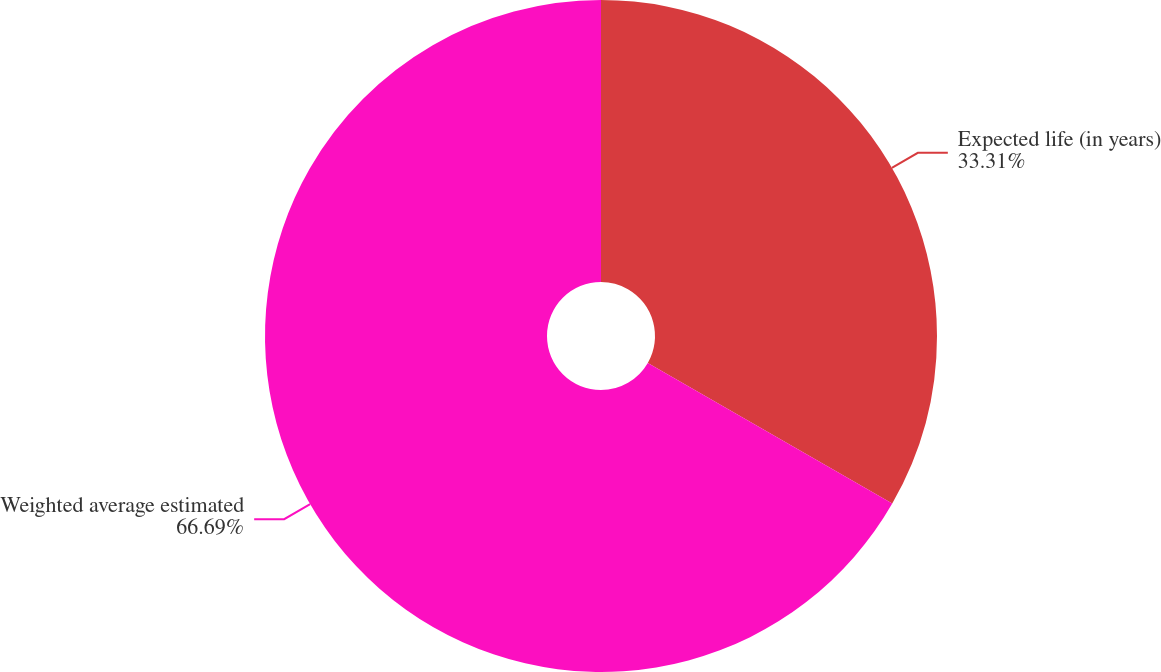Convert chart to OTSL. <chart><loc_0><loc_0><loc_500><loc_500><pie_chart><fcel>Expected life (in years)<fcel>Weighted average estimated<nl><fcel>33.31%<fcel>66.69%<nl></chart> 